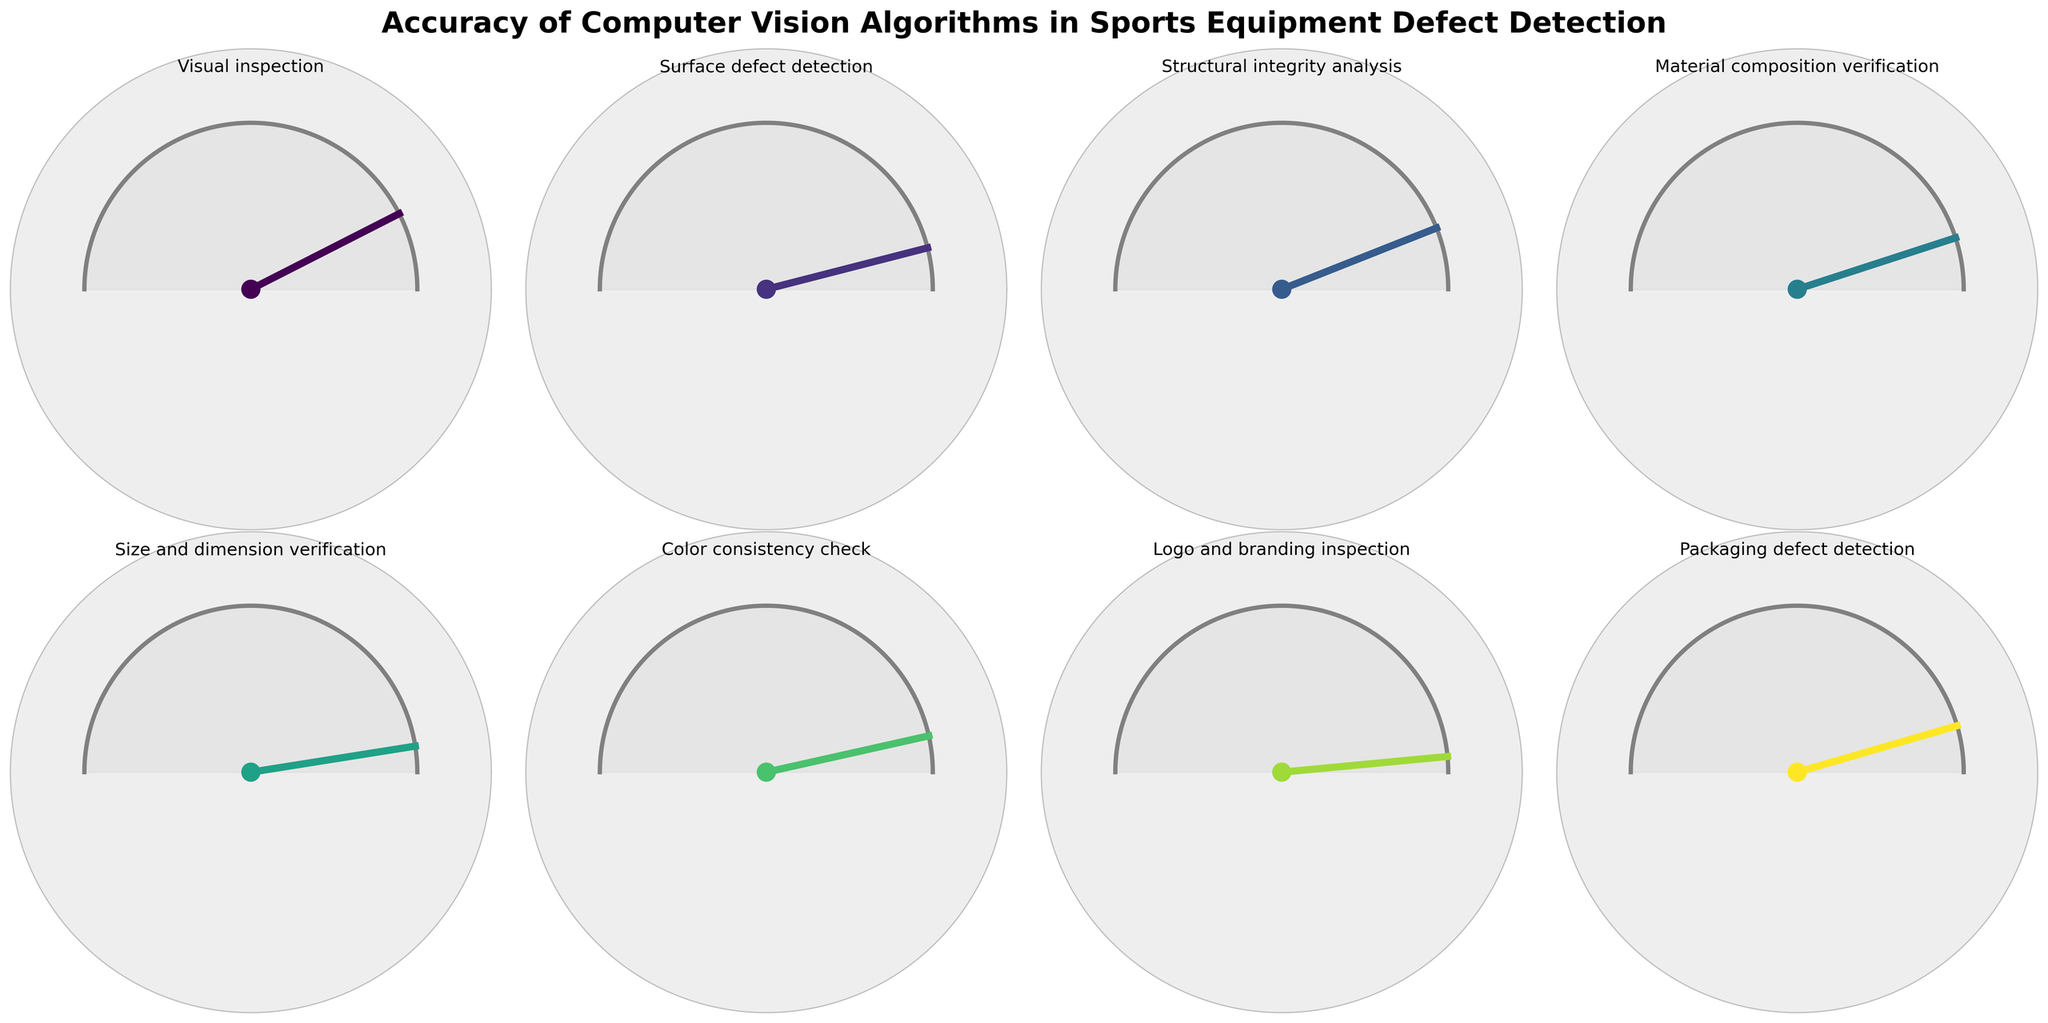What is the title of the figure? The title is usually located at the top of the figure. In this case, it reads "Accuracy of Computer Vision Algorithms in Sports Equipment Defect Detection."
Answer: Accuracy of Computer Vision Algorithms in Sports Equipment Defect Detection Which inspection type has the highest accuracy rate? To answer this, we need to find the gauge with the highest percentage value. "Logo and branding inspection" has a percentage of 97%, which is the highest.
Answer: Logo and branding inspection What is the average accuracy rate of all the detection types? Add up all accuracy rates (85 + 92 + 88 + 90 + 95 + 93 + 97 + 91) to get 731. Divide this sum by the number of types, which is 8, resulting in an average of approximately 91.375.
Answer: 91.375 Which accuracy types have a rate that is below 90%? We need to identify the types with accuracy percentages below 90%. These are "Visual inspection" with 85% and "Structural integrity analysis" with 88%.
Answer: Visual inspection, Structural integrity analysis How many inspection types have an accuracy rate of 90% or above? Count the number of types with an accuracy rate of 90% or above from the figure. They are "Surface defect detection," "Material composition verification," "Size and dimension verification," "Color consistency check," "Logo and branding inspection," and "Packaging defect detection," which adds up to 6.
Answer: 6 Which is more accurate: Surface defect detection or Packaging defect detection? Identify and compare the accuracy rates of these two types. "Surface defect detection" is 92%, while "Packaging defect detection" is 91%. Thus, "Surface defect detection" is more accurate.
Answer: Surface defect detection What is the second highest accuracy rate and which inspection type does it correspond to? First, identify the highest accuracy rate, which is 97%. The second highest is 95%, which corresponds to "Size and dimension verification".
Answer: 95%, Size and dimension verification How much higher is the accuracy rate of Logo and branding inspection compared to Color consistency check? Subtract the accuracy rate of "Color consistency check" (93%) from "Logo and branding inspection" (97%) to find the difference, which is 4%.
Answer: 4% Is the accuracy rate of Visual inspection greater or less than Structural integrity analysis? Compare the accuracy rates of "Visual inspection" (85%) and "Structural integrity analysis" (88%). "Visual inspection" is less.
Answer: Less Which inspection types have an accuracy rate between 90% and 95% inclusive? Identify types with accuracy rates in the 90%-95% range. These are "Material composition verification" (90%), "Color consistency check" (93%), and "Packaging defect detection" (91%).
Answer: Material composition verification, Color consistency check, Packaging defect detection 